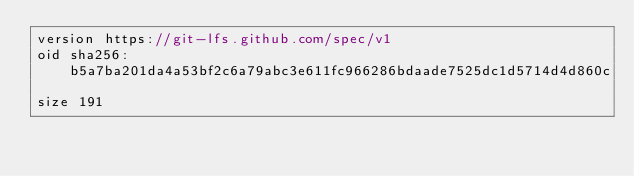<code> <loc_0><loc_0><loc_500><loc_500><_JavaScript_>version https://git-lfs.github.com/spec/v1
oid sha256:b5a7ba201da4a53bf2c6a79abc3e611fc966286bdaade7525dc1d5714d4d860c
size 191
</code> 